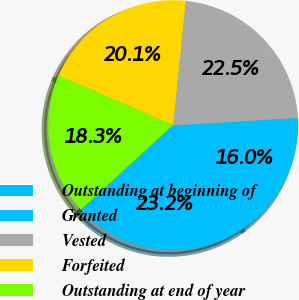Convert chart to OTSL. <chart><loc_0><loc_0><loc_500><loc_500><pie_chart><fcel>Outstanding at beginning of<fcel>Granted<fcel>Vested<fcel>Forfeited<fcel>Outstanding at end of year<nl><fcel>23.17%<fcel>15.96%<fcel>22.46%<fcel>20.09%<fcel>18.32%<nl></chart> 